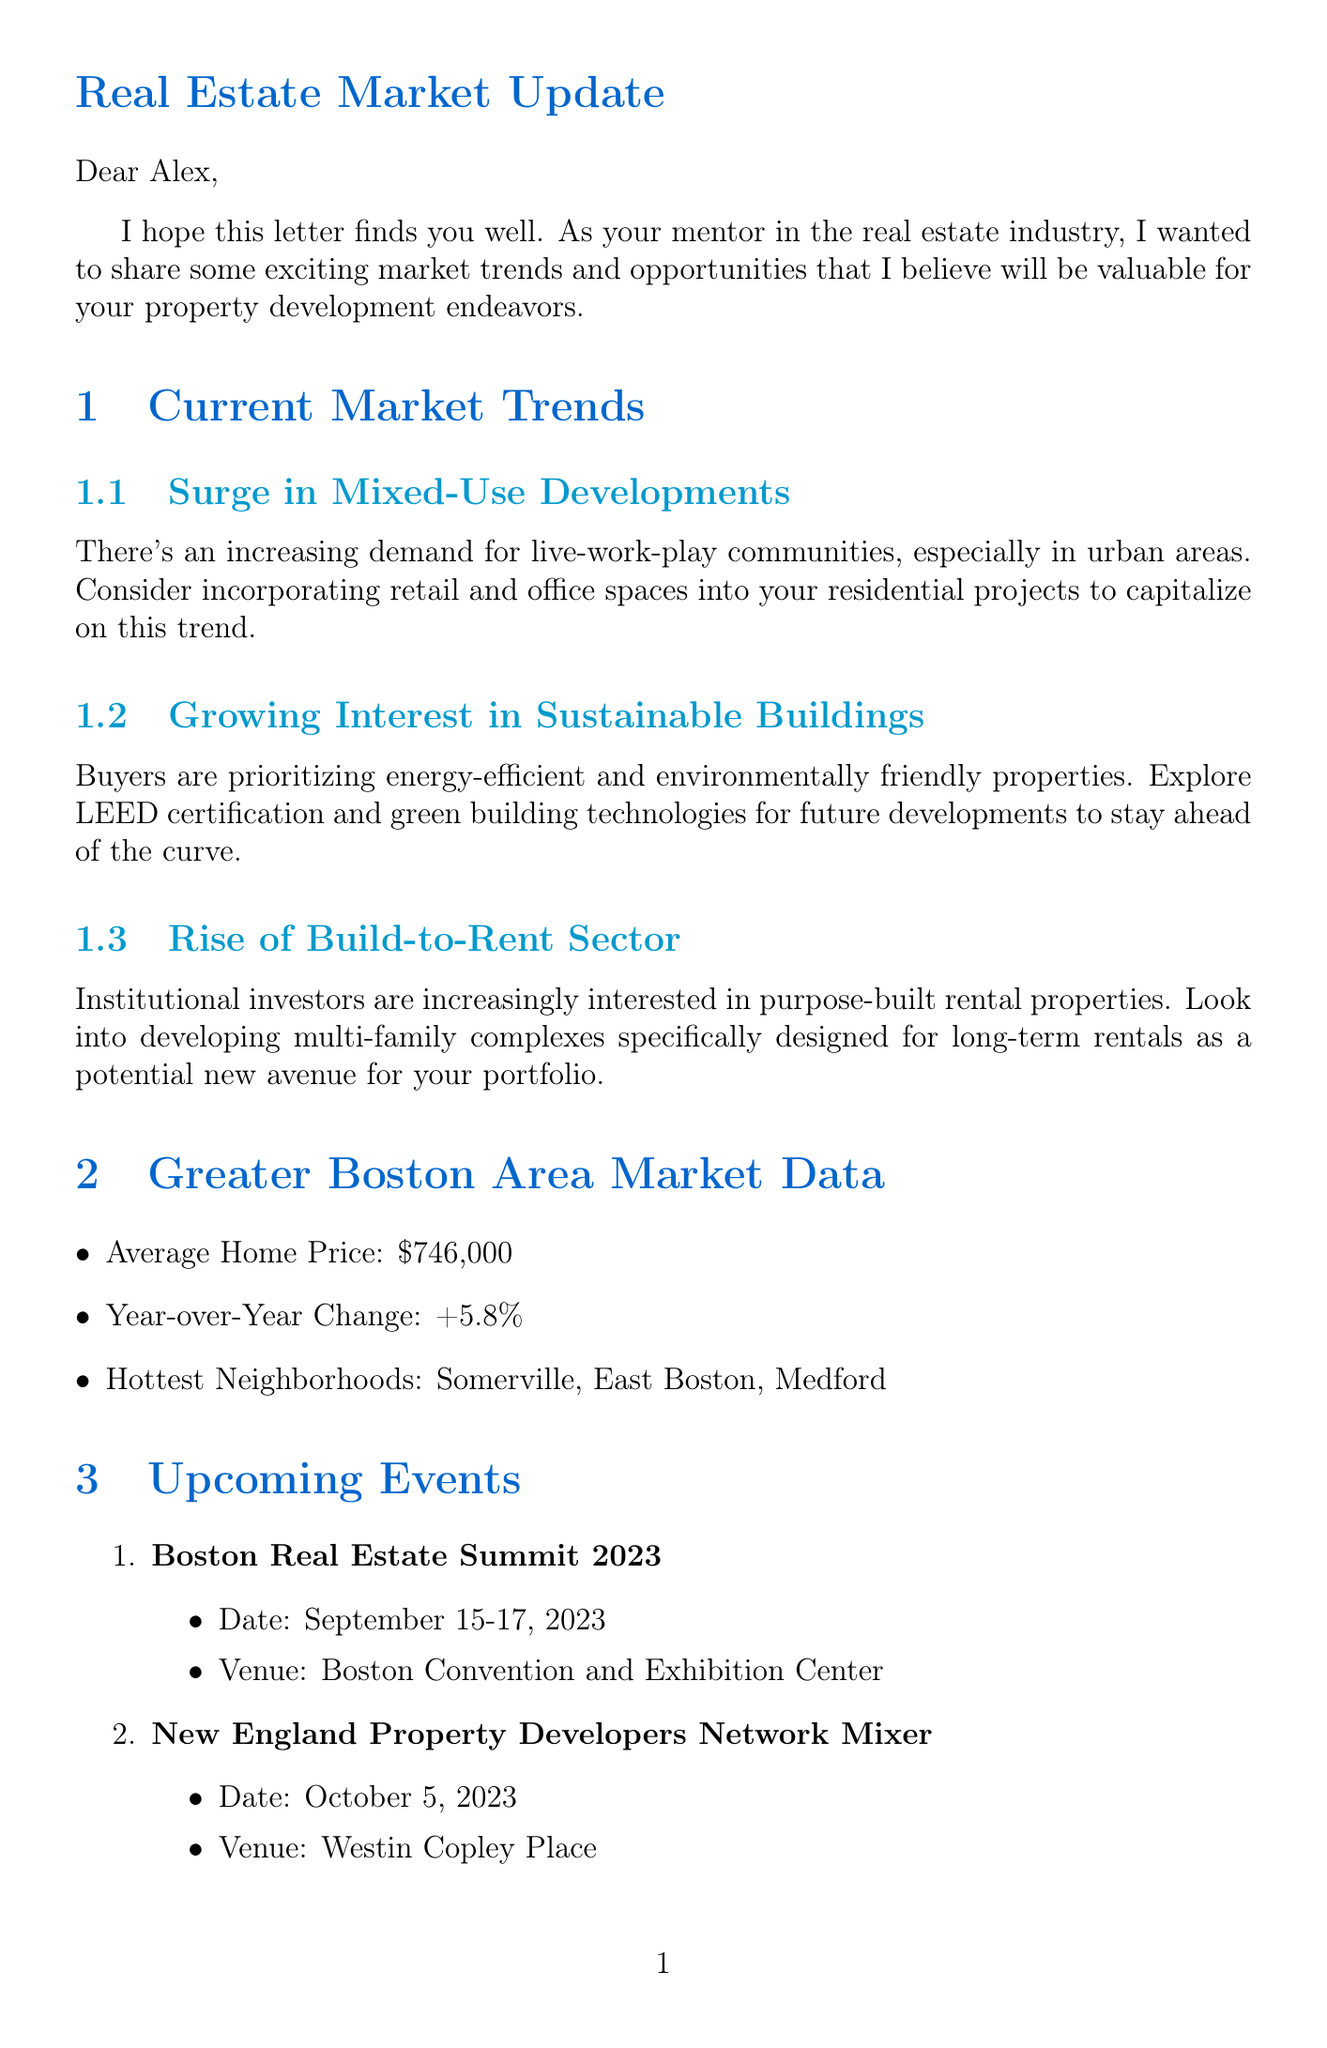What is the mentor's name? The mentor's name is mentioned at the beginning of the letter.
Answer: Sarah Thompson What is the average home price in the Greater Boston Area? The document gives a specific figure for the average home price.
Answer: $746,000 When is the Boston Real Estate Summit 2023? The event date is provided with clear details about the event.
Answer: September 15-17, 2023 What trend involves a rise in eco-friendly buildings? The document discusses a particular trend related to sustainability.
Answer: Growing interest in sustainable buildings Which neighborhoods are mentioned as the hottest in the Greater Boston Area? The document lists specific neighborhoods identified as the hottest.
Answer: Somerville, East Boston, Medford What type of resources are recommended in the letter? The types of resources provided in the document include various educational formats.
Answer: Book, Podcast, Newsletter What is the personal advice given to Alex? The document contains personal advice related to property development.
Answer: Build strong relationships with local real estate agents What sector is seeing increasing interest from institutional investors? The document identifies a specific sector attracting investor interest.
Answer: Build-to-rent sector 